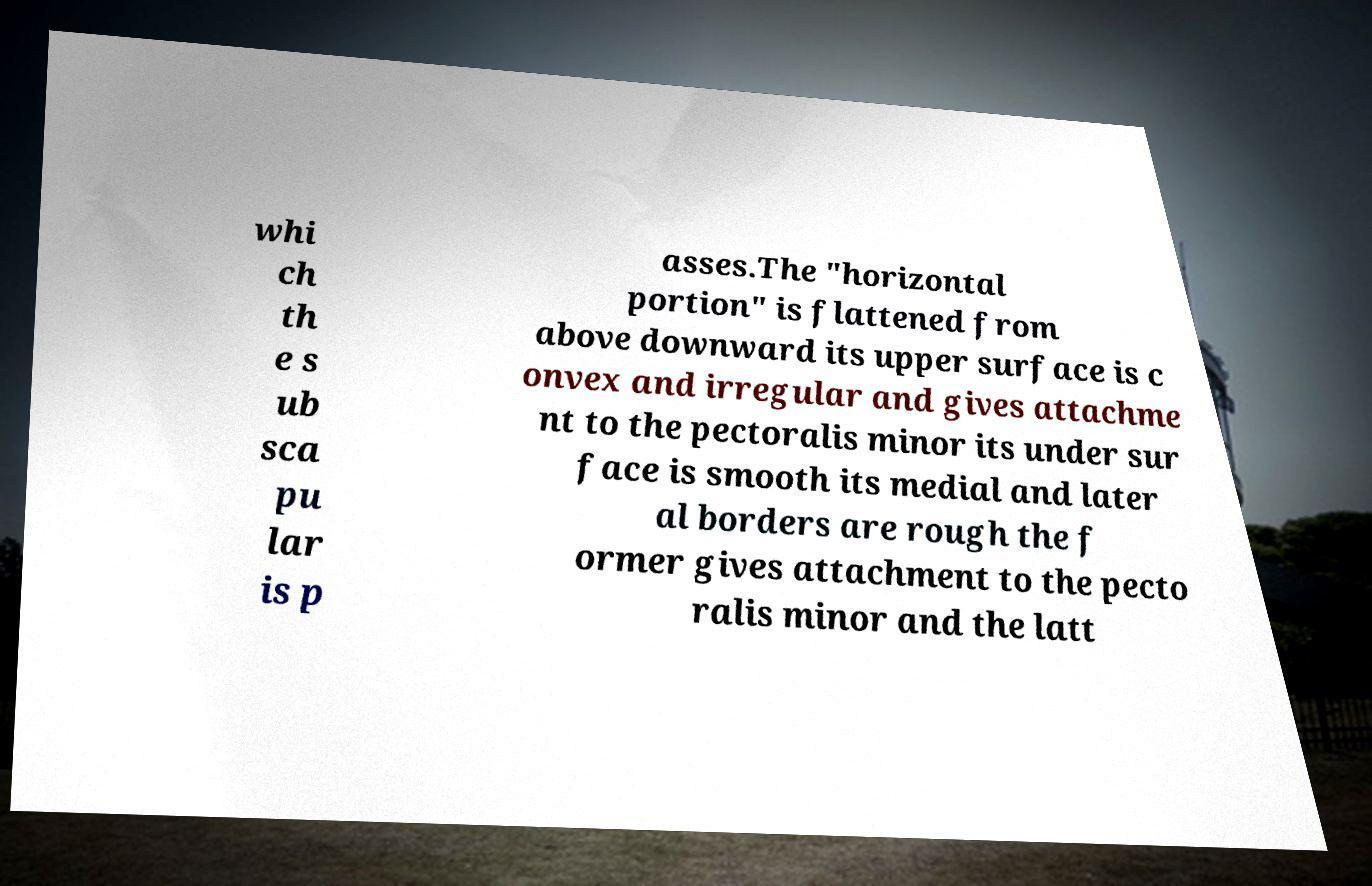Can you accurately transcribe the text from the provided image for me? whi ch th e s ub sca pu lar is p asses.The "horizontal portion" is flattened from above downward its upper surface is c onvex and irregular and gives attachme nt to the pectoralis minor its under sur face is smooth its medial and later al borders are rough the f ormer gives attachment to the pecto ralis minor and the latt 